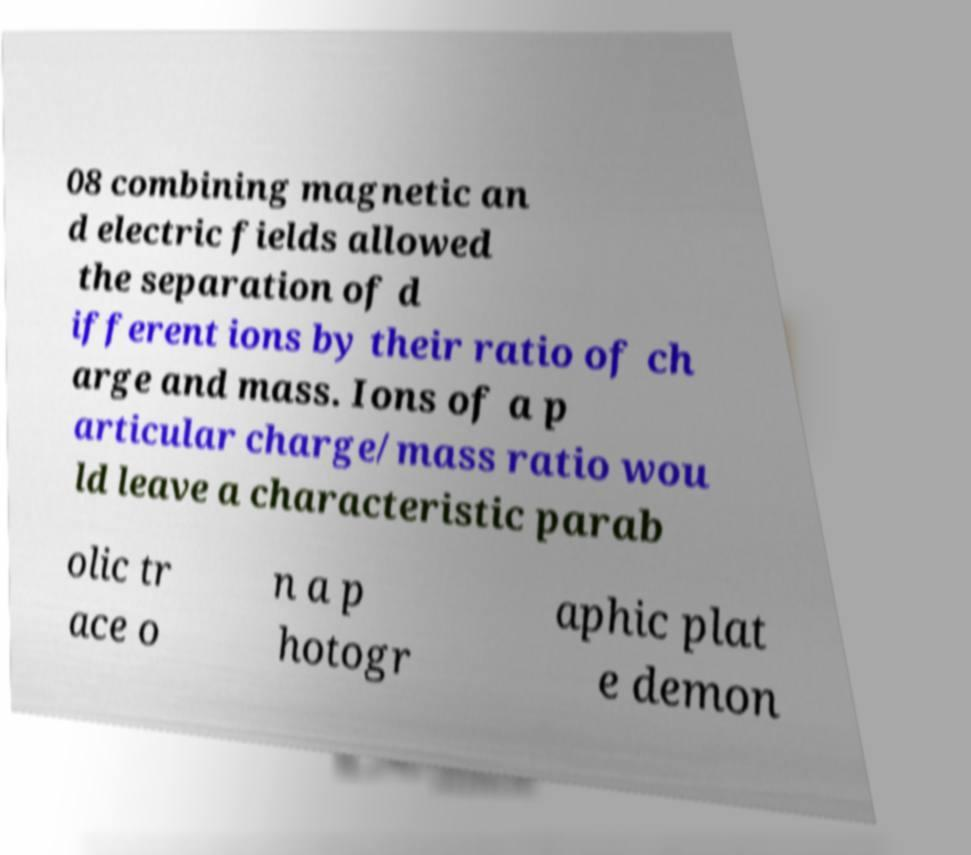Can you accurately transcribe the text from the provided image for me? 08 combining magnetic an d electric fields allowed the separation of d ifferent ions by their ratio of ch arge and mass. Ions of a p articular charge/mass ratio wou ld leave a characteristic parab olic tr ace o n a p hotogr aphic plat e demon 